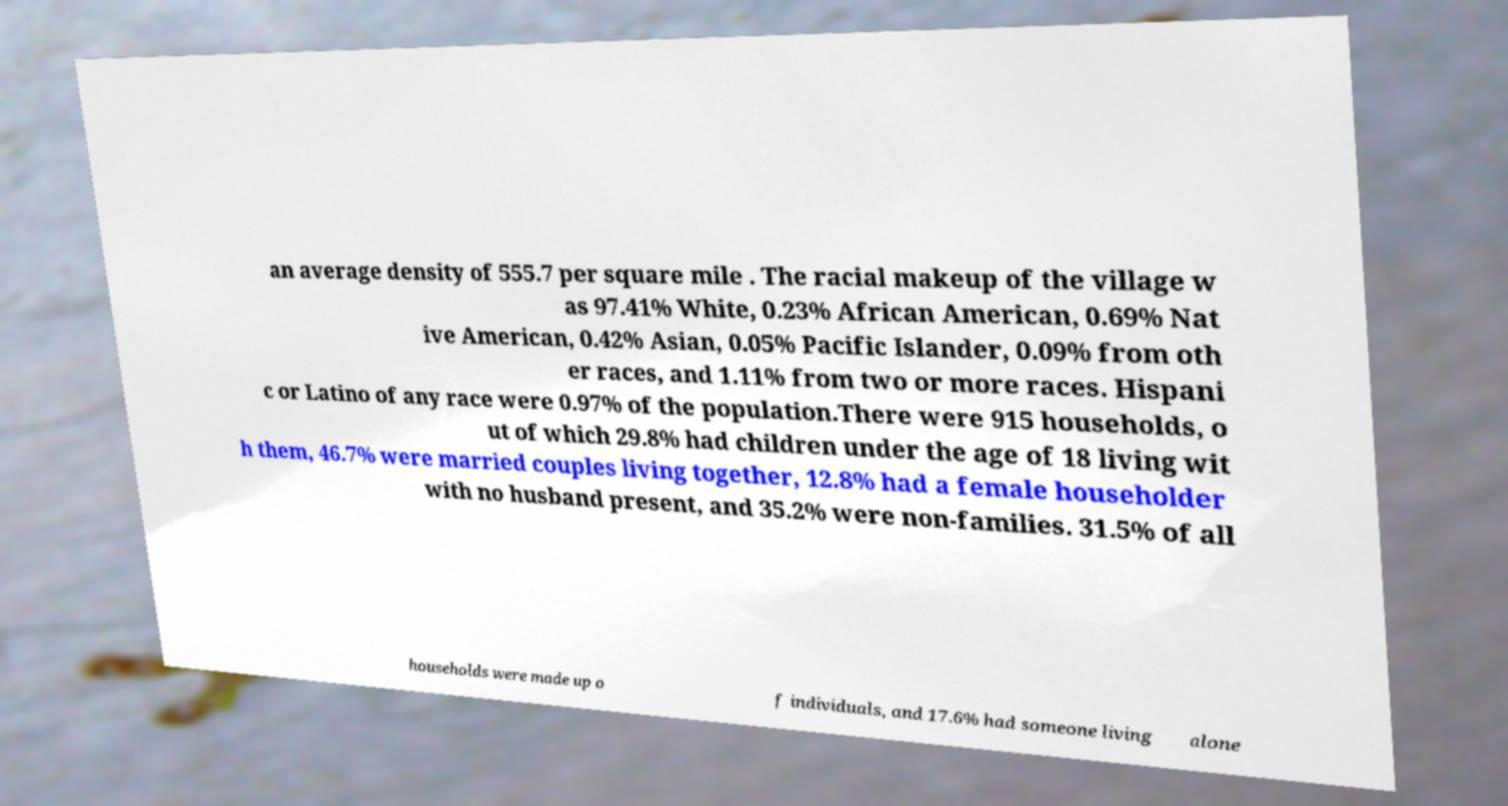There's text embedded in this image that I need extracted. Can you transcribe it verbatim? an average density of 555.7 per square mile . The racial makeup of the village w as 97.41% White, 0.23% African American, 0.69% Nat ive American, 0.42% Asian, 0.05% Pacific Islander, 0.09% from oth er races, and 1.11% from two or more races. Hispani c or Latino of any race were 0.97% of the population.There were 915 households, o ut of which 29.8% had children under the age of 18 living wit h them, 46.7% were married couples living together, 12.8% had a female householder with no husband present, and 35.2% were non-families. 31.5% of all households were made up o f individuals, and 17.6% had someone living alone 